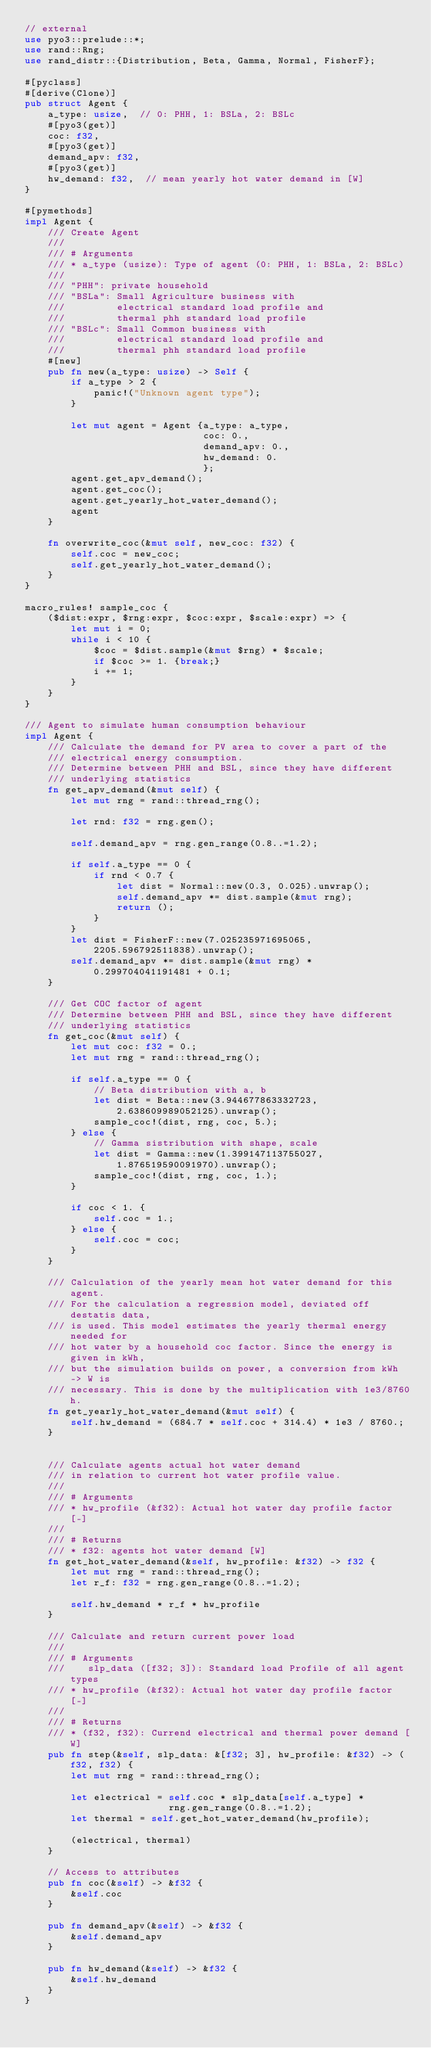<code> <loc_0><loc_0><loc_500><loc_500><_Rust_>// external
use pyo3::prelude::*;
use rand::Rng;
use rand_distr::{Distribution, Beta, Gamma, Normal, FisherF};

#[pyclass]
#[derive(Clone)]
pub struct Agent {
    a_type: usize,  // 0: PHH, 1: BSLa, 2: BSLc
    #[pyo3(get)]
    coc: f32,
    #[pyo3(get)]
    demand_apv: f32,
    #[pyo3(get)]
    hw_demand: f32,  // mean yearly hot water demand in [W]
}

#[pymethods]
impl Agent {
    /// Create Agent
    ///
    /// # Arguments
    /// * a_type (usize): Type of agent (0: PHH, 1: BSLa, 2: BSLc)
    ///
    /// "PHH": private household
    /// "BSLa": Small Agriculture business with
    ///         electrical standard load profile and
    ///         thermal phh standard load profile
    /// "BSLc": Small Common business with
    ///         electrical standard load profile and
    ///         thermal phh standard load profile
    #[new]
    pub fn new(a_type: usize) -> Self {
        if a_type > 2 {
            panic!("Unknown agent type");
        }

        let mut agent = Agent {a_type: a_type,
                               coc: 0.,
                               demand_apv: 0.,
                               hw_demand: 0.
                               };
        agent.get_apv_demand();
        agent.get_coc();
        agent.get_yearly_hot_water_demand();
        agent
    }

    fn overwrite_coc(&mut self, new_coc: f32) {
        self.coc = new_coc;
        self.get_yearly_hot_water_demand();
    }
}

macro_rules! sample_coc {
    ($dist:expr, $rng:expr, $coc:expr, $scale:expr) => {
        let mut i = 0;
        while i < 10 {
            $coc = $dist.sample(&mut $rng) * $scale;
            if $coc >= 1. {break;}
            i += 1;
        }
    }
}

/// Agent to simulate human consumption behaviour
impl Agent {
    /// Calculate the demand for PV area to cover a part of the
    /// electrical energy consumption.
    /// Determine between PHH and BSL, since they have different
    /// underlying statistics
    fn get_apv_demand(&mut self) {
        let mut rng = rand::thread_rng();

        let rnd: f32 = rng.gen();

        self.demand_apv = rng.gen_range(0.8..=1.2);

        if self.a_type == 0 {
            if rnd < 0.7 {
                let dist = Normal::new(0.3, 0.025).unwrap();
                self.demand_apv *= dist.sample(&mut rng);
                return ();
            }
        }
        let dist = FisherF::new(7.025235971695065, 2205.596792511838).unwrap();
        self.demand_apv *= dist.sample(&mut rng) * 0.299704041191481 + 0.1;
    }

    /// Get COC factor of agent
    /// Determine between PHH and BSL, since they have different
    /// underlying statistics
    fn get_coc(&mut self) {
        let mut coc: f32 = 0.;
        let mut rng = rand::thread_rng();

        if self.a_type == 0 {
            // Beta distribution with a, b
            let dist = Beta::new(3.944677863332723, 2.638609989052125).unwrap();
            sample_coc!(dist, rng, coc, 5.);
        } else {
            // Gamma sistribution with shape, scale
            let dist = Gamma::new(1.399147113755027, 1.876519590091970).unwrap();
            sample_coc!(dist, rng, coc, 1.);
        }

        if coc < 1. {
            self.coc = 1.;
        } else {
            self.coc = coc;
        }
    }

    /// Calculation of the yearly mean hot water demand for this agent.
    /// For the calculation a regression model, deviated off destatis data,
    /// is used. This model estimates the yearly thermal energy needed for
    /// hot water by a household coc factor. Since the energy is given in kWh,
    /// but the simulation builds on power, a conversion from kWh -> W is
    /// necessary. This is done by the multiplication with 1e3/8760h.
    fn get_yearly_hot_water_demand(&mut self) {
        self.hw_demand = (684.7 * self.coc + 314.4) * 1e3 / 8760.;
    }


    /// Calculate agents actual hot water demand
    /// in relation to current hot water profile value.
    ///
    /// # Arguments
    /// * hw_profile (&f32): Actual hot water day profile factor [-]
    ///
    /// # Returns
    /// * f32: agents hot water demand [W]
    fn get_hot_water_demand(&self, hw_profile: &f32) -> f32 {
        let mut rng = rand::thread_rng();
        let r_f: f32 = rng.gen_range(0.8..=1.2);

        self.hw_demand * r_f * hw_profile
    }

    /// Calculate and return current power load
    ///
    /// # Arguments
    ///    slp_data ([f32; 3]): Standard load Profile of all agent types
    /// * hw_profile (&f32): Actual hot water day profile factor [-]
    ///
    /// # Returns
    /// * (f32, f32): Currend electrical and thermal power demand [W]
    pub fn step(&self, slp_data: &[f32; 3], hw_profile: &f32) -> (f32, f32) {
        let mut rng = rand::thread_rng();

        let electrical = self.coc * slp_data[self.a_type] *
                         rng.gen_range(0.8..=1.2);
        let thermal = self.get_hot_water_demand(hw_profile);

        (electrical, thermal)
    }

    // Access to attributes
    pub fn coc(&self) -> &f32 {
        &self.coc
    }

    pub fn demand_apv(&self) -> &f32 {
        &self.demand_apv
    }

    pub fn hw_demand(&self) -> &f32 {
        &self.hw_demand
    }
}</code> 